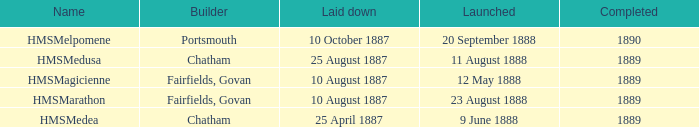When did chatham complete the Hmsmedusa? 1889.0. 